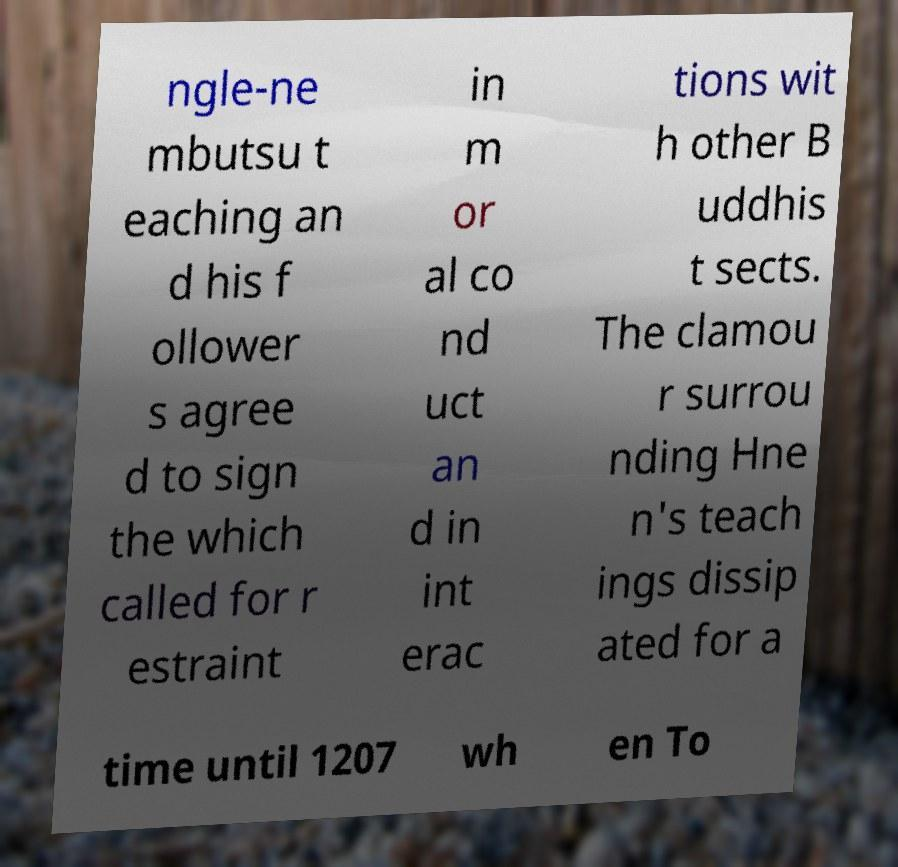What messages or text are displayed in this image? I need them in a readable, typed format. ngle-ne mbutsu t eaching an d his f ollower s agree d to sign the which called for r estraint in m or al co nd uct an d in int erac tions wit h other B uddhis t sects. The clamou r surrou nding Hne n's teach ings dissip ated for a time until 1207 wh en To 